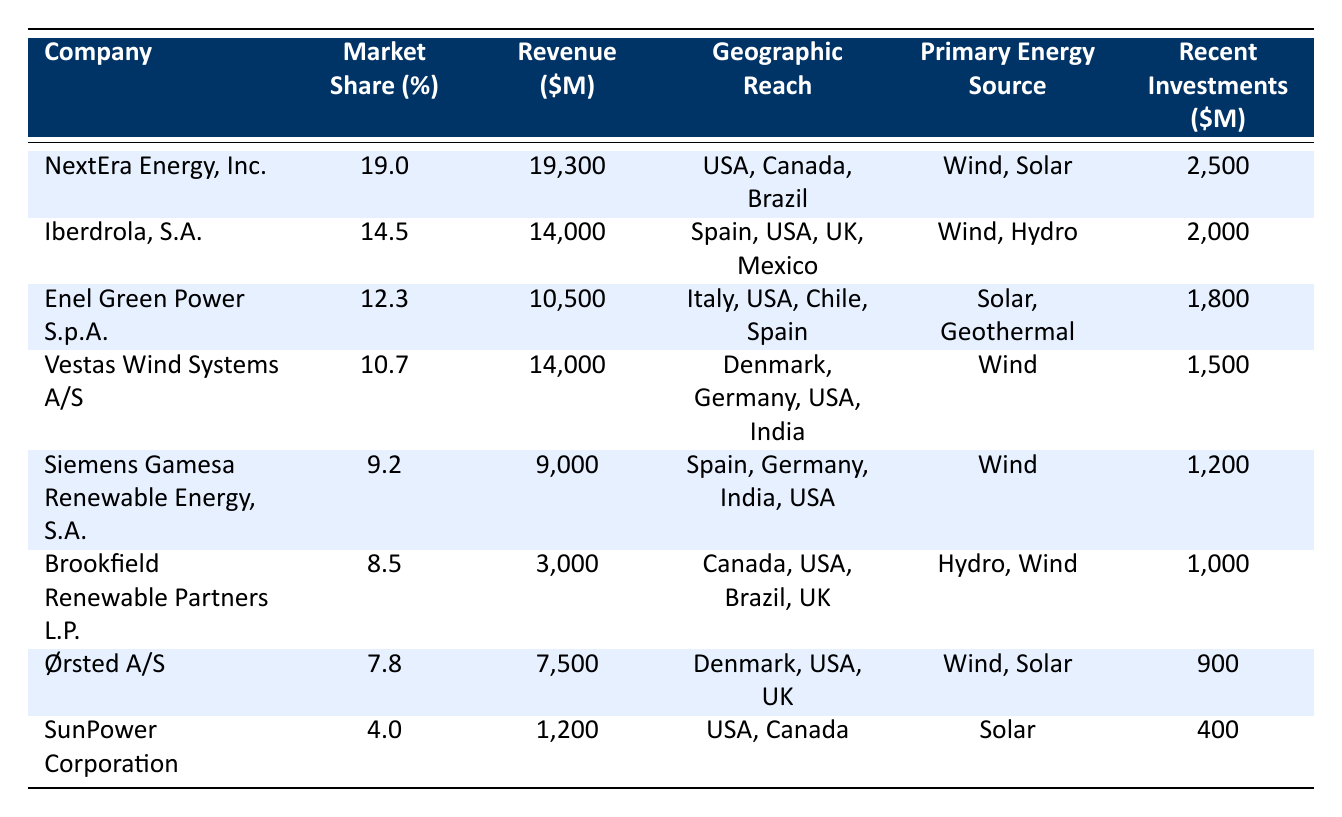What is the market share of NextEra Energy, Inc.? The table explicitly states that NextEra Energy, Inc. has a market share of 19.0%.
Answer: 19.0% Which company has the highest revenue and what is that revenue? By reviewing the revenue figures listed, NextEra Energy, Inc. has the highest revenue of $19,300 million.
Answer: $19,300 million What is the total market share of the top three companies? By adding the market shares of the top three companies: 19.0% (NextEra) + 14.5% (Iberdrola) + 12.3% (Enel Green Power) = 45.8%.
Answer: 45.8% Which company operates in the most geographic regions? By checking the geographic reach of each company, Iberdrola, S.A. operates in four regions: Spain, USA, UK, and Mexico, which is the highest.
Answer: Iberdrola, S.A Is Siemens Gamesa Renewable Energy, S.A. involved in solar energy? The table indicates that Siemens Gamesa Renewable Energy, S.A. has listed Wind as their primary energy source, with no mention of solar.
Answer: No What are the primary energy sources for the company with the lowest market share? SunPower Corporation has a market share of 4.0% and its primary energy source is Solar.
Answer: Solar What is the average revenue of the companies listed in the table? To find the average, sum the revenues ($19,300 + $14,000 + $10,500 + $14,000 + $9,000 + $3,000 + $7,500 + $1,200 = $78,500 million) and divide by the number of companies (8). This gives an average of $78,500 million / 8 = $9,812.5 million.
Answer: $9,812.5 million Which company invests the least in recent investments? The recent investments column indicates that SunPower Corporation invests the least amount at $400 million.
Answer: SunPower Corporation How much more recent investment does NextEra Energy, Inc. have compared to Ørsted A/S? Subtracting the recent investments: $2,500 million (NextEra) - $900 million (Ørsted) equals $1,600 million.
Answer: $1,600 million Are any companies listed only engaged in wind energy? The companies Vestas Wind Systems A/S and Siemens Gamesa Renewable Energy, S.A. are both engaged solely in wind energy, as indicated in their primary energy source sections.
Answer: Yes What percentage of market share do the companies with a primary energy source of solar have together? The companies with solar as a primary source are NextEra Energy, Inc. (19.0%), Enel Green Power S.p.A. (12.3%), Ørsted A/S (7.8%), and SunPower Corporation (4.0%). Adding these gives 19.0% + 12.3% + 7.8% + 4.0% = 43.1%.
Answer: 43.1% 